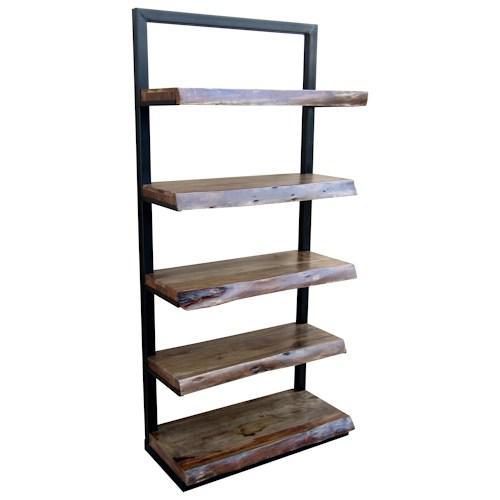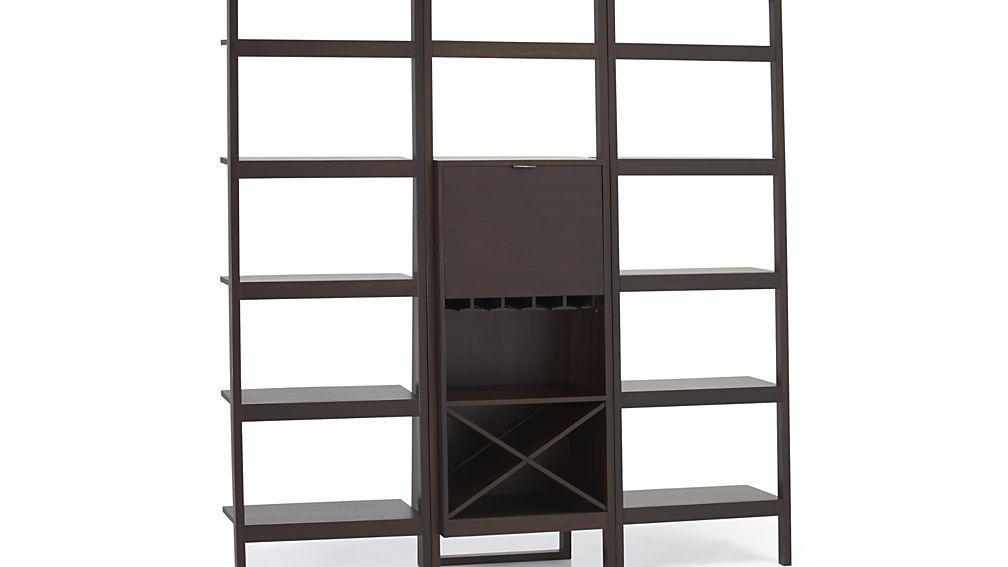The first image is the image on the left, the second image is the image on the right. For the images displayed, is the sentence "In at least one image there is a brown shelving unit with columns of shelves with the middle bottom set of selve using wood to create an x that can hold wine bottles." factually correct? Answer yes or no. Yes. 